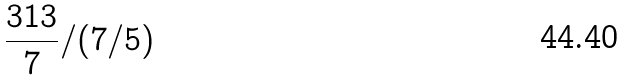<formula> <loc_0><loc_0><loc_500><loc_500>\frac { 3 1 3 } { 7 } / ( 7 / 5 )</formula> 